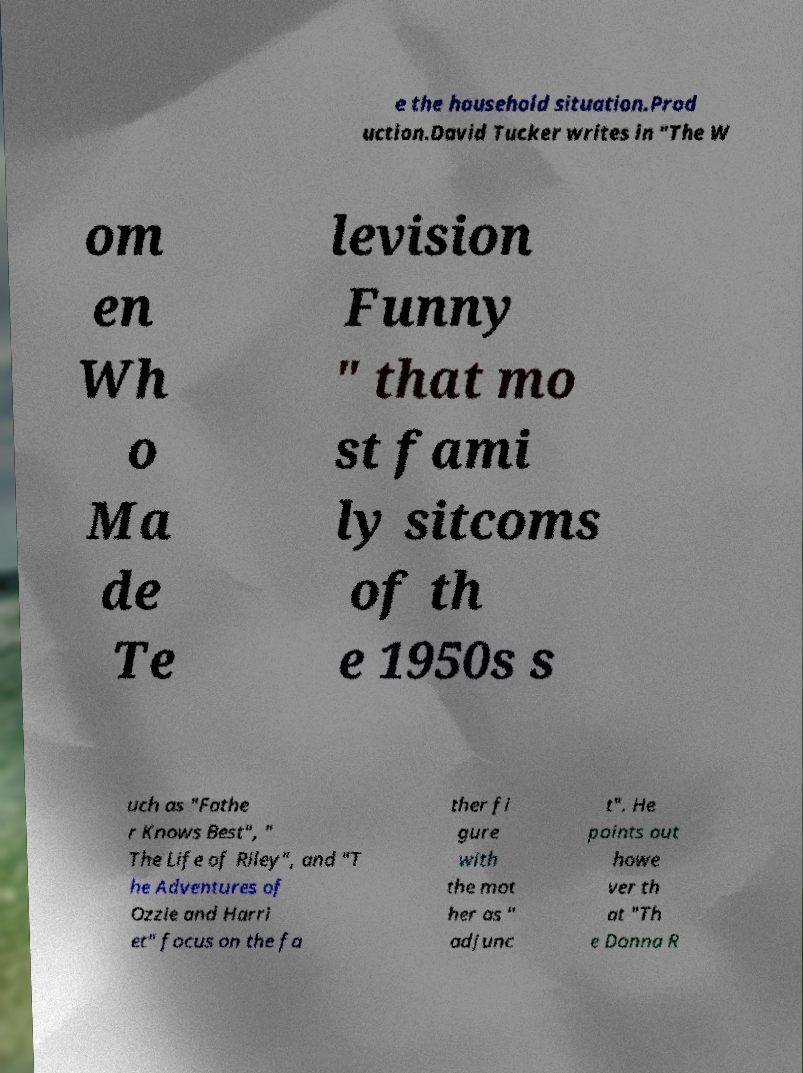I need the written content from this picture converted into text. Can you do that? e the household situation.Prod uction.David Tucker writes in "The W om en Wh o Ma de Te levision Funny " that mo st fami ly sitcoms of th e 1950s s uch as "Fathe r Knows Best", " The Life of Riley", and "T he Adventures of Ozzie and Harri et" focus on the fa ther fi gure with the mot her as " adjunc t". He points out howe ver th at "Th e Donna R 